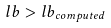<formula> <loc_0><loc_0><loc_500><loc_500>l b > l b _ { c o m p u t e d }</formula> 